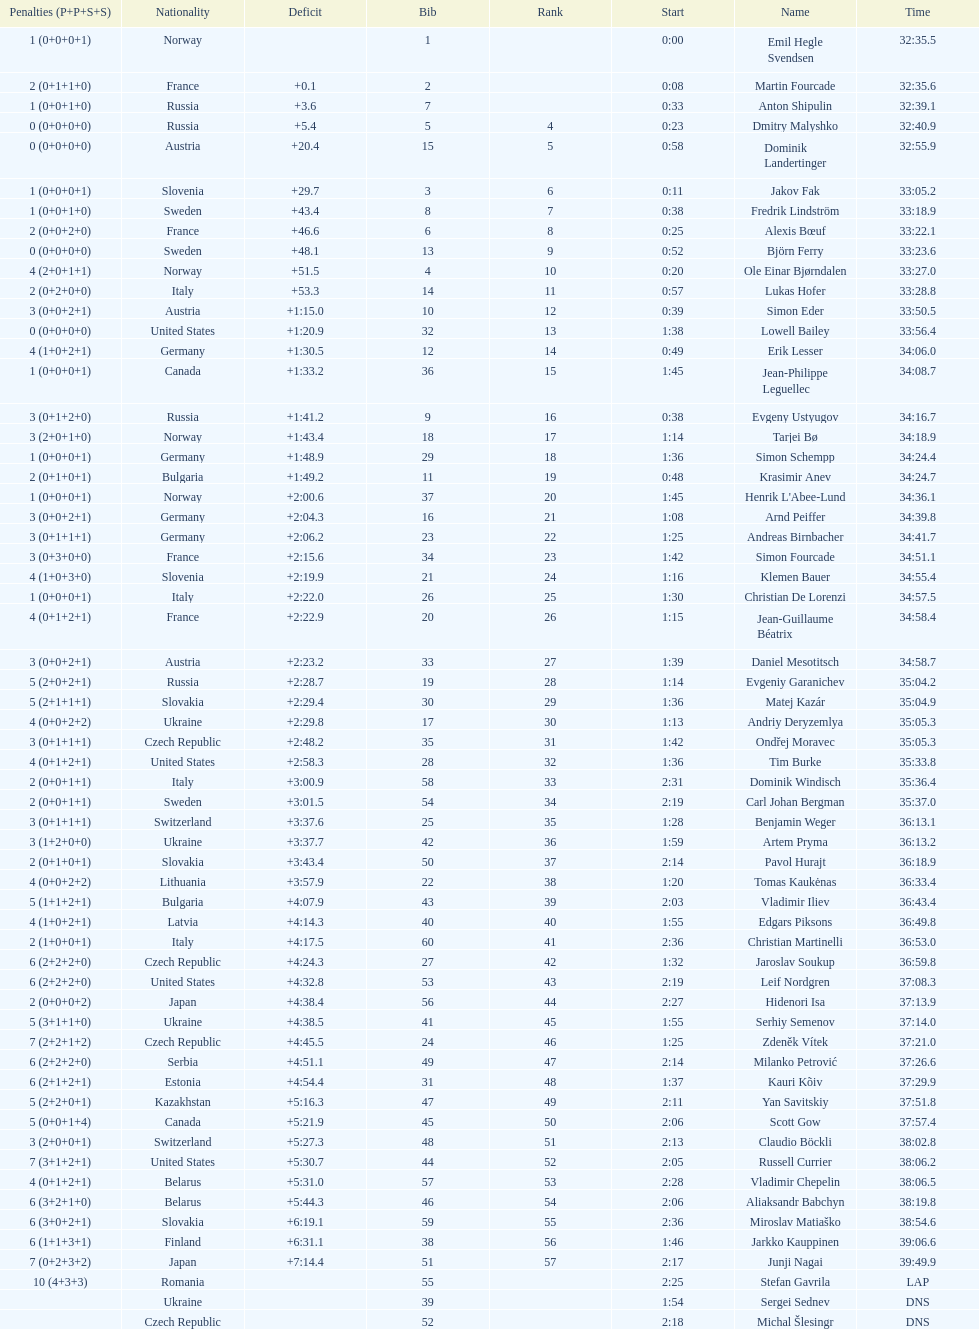What is the largest penalty? 10. Could you parse the entire table as a dict? {'header': ['Penalties (P+P+S+S)', 'Nationality', 'Deficit', 'Bib', 'Rank', 'Start', 'Name', 'Time'], 'rows': [['1 (0+0+0+1)', 'Norway', '', '1', '', '0:00', 'Emil Hegle Svendsen', '32:35.5'], ['2 (0+1+1+0)', 'France', '+0.1', '2', '', '0:08', 'Martin Fourcade', '32:35.6'], ['1 (0+0+1+0)', 'Russia', '+3.6', '7', '', '0:33', 'Anton Shipulin', '32:39.1'], ['0 (0+0+0+0)', 'Russia', '+5.4', '5', '4', '0:23', 'Dmitry Malyshko', '32:40.9'], ['0 (0+0+0+0)', 'Austria', '+20.4', '15', '5', '0:58', 'Dominik Landertinger', '32:55.9'], ['1 (0+0+0+1)', 'Slovenia', '+29.7', '3', '6', '0:11', 'Jakov Fak', '33:05.2'], ['1 (0+0+1+0)', 'Sweden', '+43.4', '8', '7', '0:38', 'Fredrik Lindström', '33:18.9'], ['2 (0+0+2+0)', 'France', '+46.6', '6', '8', '0:25', 'Alexis Bœuf', '33:22.1'], ['0 (0+0+0+0)', 'Sweden', '+48.1', '13', '9', '0:52', 'Björn Ferry', '33:23.6'], ['4 (2+0+1+1)', 'Norway', '+51.5', '4', '10', '0:20', 'Ole Einar Bjørndalen', '33:27.0'], ['2 (0+2+0+0)', 'Italy', '+53.3', '14', '11', '0:57', 'Lukas Hofer', '33:28.8'], ['3 (0+0+2+1)', 'Austria', '+1:15.0', '10', '12', '0:39', 'Simon Eder', '33:50.5'], ['0 (0+0+0+0)', 'United States', '+1:20.9', '32', '13', '1:38', 'Lowell Bailey', '33:56.4'], ['4 (1+0+2+1)', 'Germany', '+1:30.5', '12', '14', '0:49', 'Erik Lesser', '34:06.0'], ['1 (0+0+0+1)', 'Canada', '+1:33.2', '36', '15', '1:45', 'Jean-Philippe Leguellec', '34:08.7'], ['3 (0+1+2+0)', 'Russia', '+1:41.2', '9', '16', '0:38', 'Evgeny Ustyugov', '34:16.7'], ['3 (2+0+1+0)', 'Norway', '+1:43.4', '18', '17', '1:14', 'Tarjei Bø', '34:18.9'], ['1 (0+0+0+1)', 'Germany', '+1:48.9', '29', '18', '1:36', 'Simon Schempp', '34:24.4'], ['2 (0+1+0+1)', 'Bulgaria', '+1:49.2', '11', '19', '0:48', 'Krasimir Anev', '34:24.7'], ['1 (0+0+0+1)', 'Norway', '+2:00.6', '37', '20', '1:45', "Henrik L'Abee-Lund", '34:36.1'], ['3 (0+0+2+1)', 'Germany', '+2:04.3', '16', '21', '1:08', 'Arnd Peiffer', '34:39.8'], ['3 (0+1+1+1)', 'Germany', '+2:06.2', '23', '22', '1:25', 'Andreas Birnbacher', '34:41.7'], ['3 (0+3+0+0)', 'France', '+2:15.6', '34', '23', '1:42', 'Simon Fourcade', '34:51.1'], ['4 (1+0+3+0)', 'Slovenia', '+2:19.9', '21', '24', '1:16', 'Klemen Bauer', '34:55.4'], ['1 (0+0+0+1)', 'Italy', '+2:22.0', '26', '25', '1:30', 'Christian De Lorenzi', '34:57.5'], ['4 (0+1+2+1)', 'France', '+2:22.9', '20', '26', '1:15', 'Jean-Guillaume Béatrix', '34:58.4'], ['3 (0+0+2+1)', 'Austria', '+2:23.2', '33', '27', '1:39', 'Daniel Mesotitsch', '34:58.7'], ['5 (2+0+2+1)', 'Russia', '+2:28.7', '19', '28', '1:14', 'Evgeniy Garanichev', '35:04.2'], ['5 (2+1+1+1)', 'Slovakia', '+2:29.4', '30', '29', '1:36', 'Matej Kazár', '35:04.9'], ['4 (0+0+2+2)', 'Ukraine', '+2:29.8', '17', '30', '1:13', 'Andriy Deryzemlya', '35:05.3'], ['3 (0+1+1+1)', 'Czech Republic', '+2:48.2', '35', '31', '1:42', 'Ondřej Moravec', '35:05.3'], ['4 (0+1+2+1)', 'United States', '+2:58.3', '28', '32', '1:36', 'Tim Burke', '35:33.8'], ['2 (0+0+1+1)', 'Italy', '+3:00.9', '58', '33', '2:31', 'Dominik Windisch', '35:36.4'], ['2 (0+0+1+1)', 'Sweden', '+3:01.5', '54', '34', '2:19', 'Carl Johan Bergman', '35:37.0'], ['3 (0+1+1+1)', 'Switzerland', '+3:37.6', '25', '35', '1:28', 'Benjamin Weger', '36:13.1'], ['3 (1+2+0+0)', 'Ukraine', '+3:37.7', '42', '36', '1:59', 'Artem Pryma', '36:13.2'], ['2 (0+1+0+1)', 'Slovakia', '+3:43.4', '50', '37', '2:14', 'Pavol Hurajt', '36:18.9'], ['4 (0+0+2+2)', 'Lithuania', '+3:57.9', '22', '38', '1:20', 'Tomas Kaukėnas', '36:33.4'], ['5 (1+1+2+1)', 'Bulgaria', '+4:07.9', '43', '39', '2:03', 'Vladimir Iliev', '36:43.4'], ['4 (1+0+2+1)', 'Latvia', '+4:14.3', '40', '40', '1:55', 'Edgars Piksons', '36:49.8'], ['2 (1+0+0+1)', 'Italy', '+4:17.5', '60', '41', '2:36', 'Christian Martinelli', '36:53.0'], ['6 (2+2+2+0)', 'Czech Republic', '+4:24.3', '27', '42', '1:32', 'Jaroslav Soukup', '36:59.8'], ['6 (2+2+2+0)', 'United States', '+4:32.8', '53', '43', '2:19', 'Leif Nordgren', '37:08.3'], ['2 (0+0+0+2)', 'Japan', '+4:38.4', '56', '44', '2:27', 'Hidenori Isa', '37:13.9'], ['5 (3+1+1+0)', 'Ukraine', '+4:38.5', '41', '45', '1:55', 'Serhiy Semenov', '37:14.0'], ['7 (2+2+1+2)', 'Czech Republic', '+4:45.5', '24', '46', '1:25', 'Zdeněk Vítek', '37:21.0'], ['6 (2+2+2+0)', 'Serbia', '+4:51.1', '49', '47', '2:14', 'Milanko Petrović', '37:26.6'], ['6 (2+1+2+1)', 'Estonia', '+4:54.4', '31', '48', '1:37', 'Kauri Kõiv', '37:29.9'], ['5 (2+2+0+1)', 'Kazakhstan', '+5:16.3', '47', '49', '2:11', 'Yan Savitskiy', '37:51.8'], ['5 (0+0+1+4)', 'Canada', '+5:21.9', '45', '50', '2:06', 'Scott Gow', '37:57.4'], ['3 (2+0+0+1)', 'Switzerland', '+5:27.3', '48', '51', '2:13', 'Claudio Böckli', '38:02.8'], ['7 (3+1+2+1)', 'United States', '+5:30.7', '44', '52', '2:05', 'Russell Currier', '38:06.2'], ['4 (0+1+2+1)', 'Belarus', '+5:31.0', '57', '53', '2:28', 'Vladimir Chepelin', '38:06.5'], ['6 (3+2+1+0)', 'Belarus', '+5:44.3', '46', '54', '2:06', 'Aliaksandr Babchyn', '38:19.8'], ['6 (3+0+2+1)', 'Slovakia', '+6:19.1', '59', '55', '2:36', 'Miroslav Matiaško', '38:54.6'], ['6 (1+1+3+1)', 'Finland', '+6:31.1', '38', '56', '1:46', 'Jarkko Kauppinen', '39:06.6'], ['7 (0+2+3+2)', 'Japan', '+7:14.4', '51', '57', '2:17', 'Junji Nagai', '39:49.9'], ['10 (4+3+3)', 'Romania', '', '55', '', '2:25', 'Stefan Gavrila', 'LAP'], ['', 'Ukraine', '', '39', '', '1:54', 'Sergei Sednev', 'DNS'], ['', 'Czech Republic', '', '52', '', '2:18', 'Michal Šlesingr', 'DNS']]} 